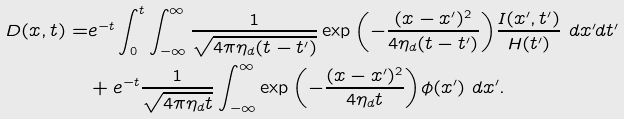<formula> <loc_0><loc_0><loc_500><loc_500>D ( x , t ) = & e ^ { - t } \int _ { 0 } ^ { t } { \int _ { - \infty } ^ { \infty } { \frac { 1 } { \sqrt { 4 \pi \eta _ { d } ( t - t ^ { \prime } ) } } \exp { \left ( - \frac { ( x - x ^ { \prime } ) ^ { 2 } } { 4 \eta _ { d } ( t - t ^ { \prime } ) } \right ) } \frac { I ( x ^ { \prime } , t ^ { \prime } ) } { H ( t ^ { \prime } ) } } } \ d x ^ { \prime } d t ^ { \prime } \\ & + e ^ { - t } \frac { 1 } { \sqrt { 4 \pi \eta _ { d } t } } \int _ { - \infty } ^ { \infty } { \exp { \left ( - \frac { ( x - x ^ { \prime } ) ^ { 2 } } { 4 \eta _ { d } t } \right ) } \phi ( x ^ { \prime } ) } \ d x ^ { \prime } .</formula> 